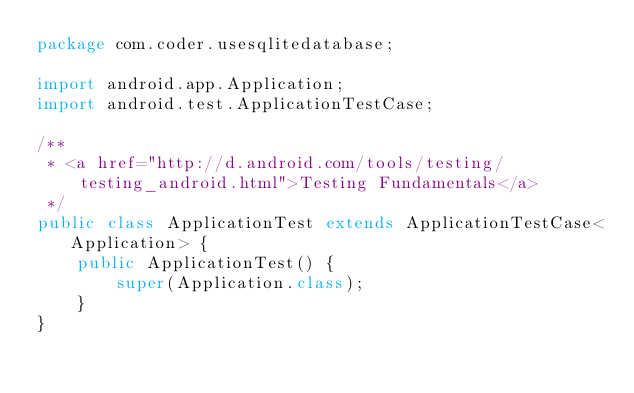<code> <loc_0><loc_0><loc_500><loc_500><_Java_>package com.coder.usesqlitedatabase;

import android.app.Application;
import android.test.ApplicationTestCase;

/**
 * <a href="http://d.android.com/tools/testing/testing_android.html">Testing Fundamentals</a>
 */
public class ApplicationTest extends ApplicationTestCase<Application> {
    public ApplicationTest() {
        super(Application.class);
    }
}</code> 